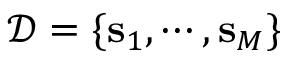<formula> <loc_0><loc_0><loc_500><loc_500>\mathcal { D } = \{ s _ { 1 } , \cdots , s _ { M } \}</formula> 